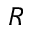Convert formula to latex. <formula><loc_0><loc_0><loc_500><loc_500>R</formula> 